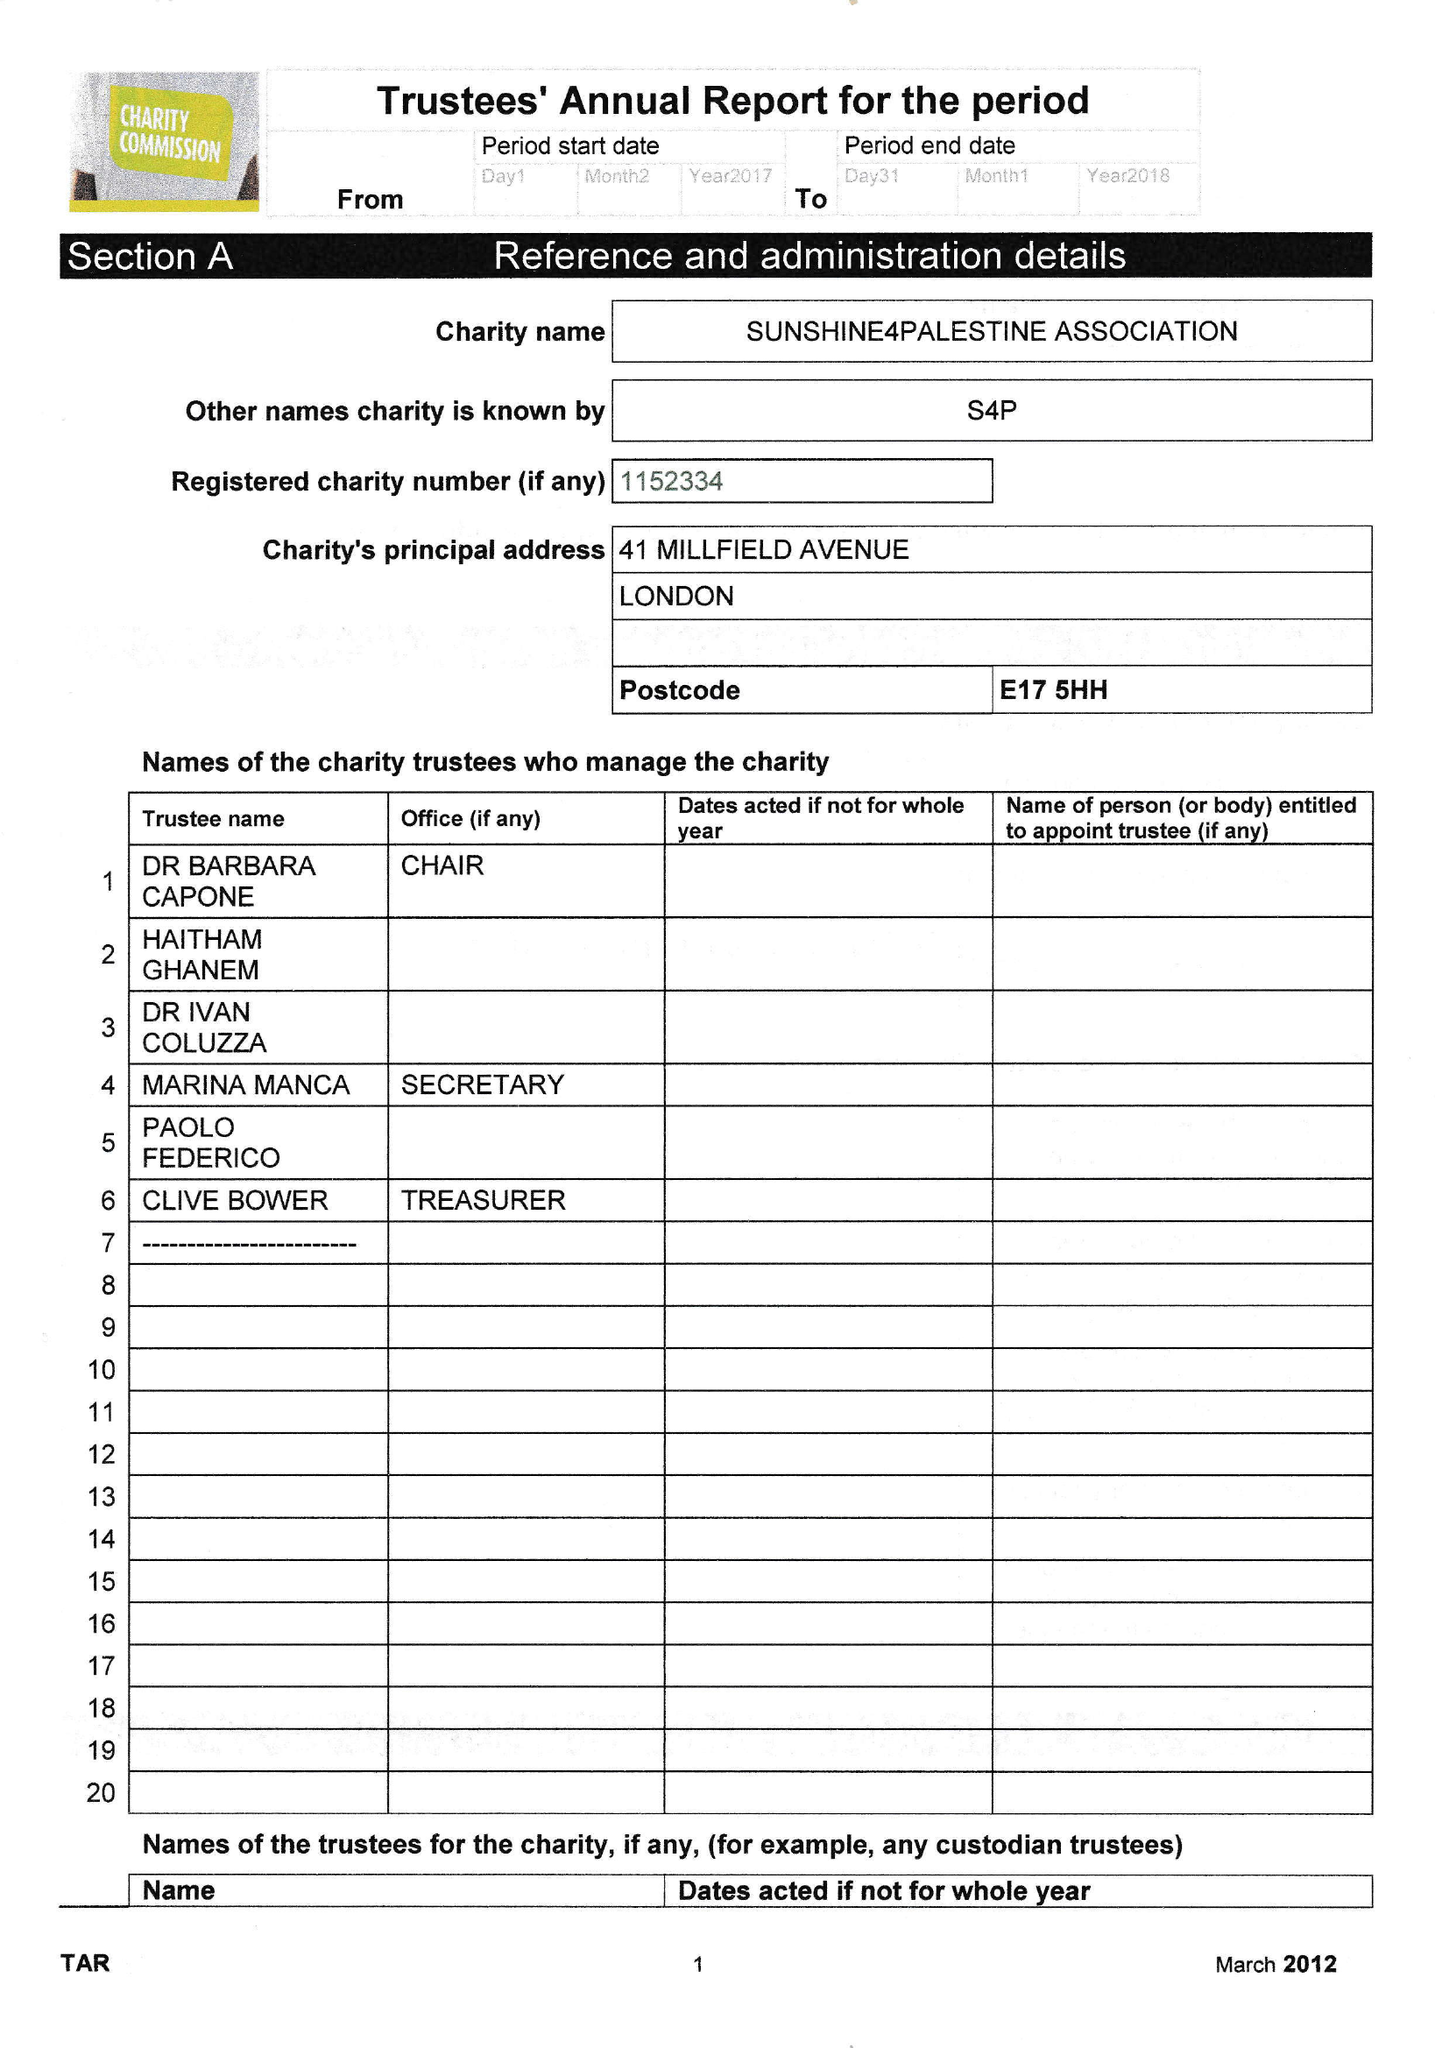What is the value for the spending_annually_in_british_pounds?
Answer the question using a single word or phrase. 19.00 